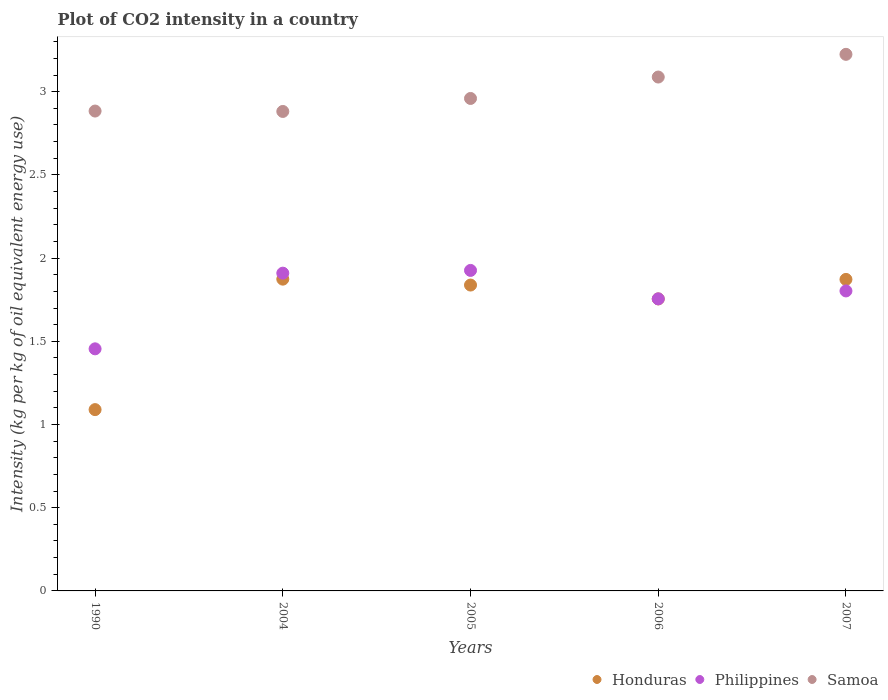Is the number of dotlines equal to the number of legend labels?
Offer a terse response. Yes. What is the CO2 intensity in in Honduras in 2004?
Your response must be concise. 1.87. Across all years, what is the maximum CO2 intensity in in Philippines?
Your response must be concise. 1.93. Across all years, what is the minimum CO2 intensity in in Samoa?
Your answer should be compact. 2.88. In which year was the CO2 intensity in in Philippines maximum?
Your answer should be very brief. 2005. In which year was the CO2 intensity in in Philippines minimum?
Provide a short and direct response. 1990. What is the total CO2 intensity in in Honduras in the graph?
Provide a succinct answer. 8.43. What is the difference between the CO2 intensity in in Philippines in 2004 and that in 2007?
Give a very brief answer. 0.11. What is the difference between the CO2 intensity in in Samoa in 2006 and the CO2 intensity in in Philippines in 2005?
Ensure brevity in your answer.  1.16. What is the average CO2 intensity in in Philippines per year?
Give a very brief answer. 1.77. In the year 2004, what is the difference between the CO2 intensity in in Samoa and CO2 intensity in in Honduras?
Provide a short and direct response. 1.01. What is the ratio of the CO2 intensity in in Honduras in 2006 to that in 2007?
Offer a terse response. 0.94. Is the CO2 intensity in in Samoa in 1990 less than that in 2006?
Keep it short and to the point. Yes. What is the difference between the highest and the second highest CO2 intensity in in Samoa?
Your answer should be very brief. 0.14. What is the difference between the highest and the lowest CO2 intensity in in Philippines?
Keep it short and to the point. 0.47. In how many years, is the CO2 intensity in in Honduras greater than the average CO2 intensity in in Honduras taken over all years?
Make the answer very short. 4. Is it the case that in every year, the sum of the CO2 intensity in in Philippines and CO2 intensity in in Samoa  is greater than the CO2 intensity in in Honduras?
Your response must be concise. Yes. Is the CO2 intensity in in Honduras strictly greater than the CO2 intensity in in Samoa over the years?
Ensure brevity in your answer.  No. What is the difference between two consecutive major ticks on the Y-axis?
Your answer should be very brief. 0.5. Are the values on the major ticks of Y-axis written in scientific E-notation?
Provide a short and direct response. No. Does the graph contain any zero values?
Your answer should be compact. No. Where does the legend appear in the graph?
Offer a very short reply. Bottom right. How many legend labels are there?
Provide a short and direct response. 3. What is the title of the graph?
Make the answer very short. Plot of CO2 intensity in a country. Does "Albania" appear as one of the legend labels in the graph?
Provide a short and direct response. No. What is the label or title of the Y-axis?
Ensure brevity in your answer.  Intensity (kg per kg of oil equivalent energy use). What is the Intensity (kg per kg of oil equivalent energy use) in Honduras in 1990?
Provide a short and direct response. 1.09. What is the Intensity (kg per kg of oil equivalent energy use) in Philippines in 1990?
Your answer should be very brief. 1.45. What is the Intensity (kg per kg of oil equivalent energy use) of Samoa in 1990?
Your answer should be compact. 2.88. What is the Intensity (kg per kg of oil equivalent energy use) of Honduras in 2004?
Keep it short and to the point. 1.87. What is the Intensity (kg per kg of oil equivalent energy use) in Philippines in 2004?
Your answer should be very brief. 1.91. What is the Intensity (kg per kg of oil equivalent energy use) in Samoa in 2004?
Offer a very short reply. 2.88. What is the Intensity (kg per kg of oil equivalent energy use) in Honduras in 2005?
Your response must be concise. 1.84. What is the Intensity (kg per kg of oil equivalent energy use) of Philippines in 2005?
Ensure brevity in your answer.  1.93. What is the Intensity (kg per kg of oil equivalent energy use) of Samoa in 2005?
Give a very brief answer. 2.96. What is the Intensity (kg per kg of oil equivalent energy use) in Honduras in 2006?
Keep it short and to the point. 1.75. What is the Intensity (kg per kg of oil equivalent energy use) of Philippines in 2006?
Offer a terse response. 1.76. What is the Intensity (kg per kg of oil equivalent energy use) of Samoa in 2006?
Provide a short and direct response. 3.09. What is the Intensity (kg per kg of oil equivalent energy use) of Honduras in 2007?
Your answer should be compact. 1.87. What is the Intensity (kg per kg of oil equivalent energy use) in Philippines in 2007?
Give a very brief answer. 1.8. What is the Intensity (kg per kg of oil equivalent energy use) in Samoa in 2007?
Make the answer very short. 3.22. Across all years, what is the maximum Intensity (kg per kg of oil equivalent energy use) of Honduras?
Give a very brief answer. 1.87. Across all years, what is the maximum Intensity (kg per kg of oil equivalent energy use) in Philippines?
Make the answer very short. 1.93. Across all years, what is the maximum Intensity (kg per kg of oil equivalent energy use) of Samoa?
Offer a terse response. 3.22. Across all years, what is the minimum Intensity (kg per kg of oil equivalent energy use) of Honduras?
Make the answer very short. 1.09. Across all years, what is the minimum Intensity (kg per kg of oil equivalent energy use) in Philippines?
Offer a terse response. 1.45. Across all years, what is the minimum Intensity (kg per kg of oil equivalent energy use) in Samoa?
Ensure brevity in your answer.  2.88. What is the total Intensity (kg per kg of oil equivalent energy use) of Honduras in the graph?
Provide a succinct answer. 8.43. What is the total Intensity (kg per kg of oil equivalent energy use) in Philippines in the graph?
Your response must be concise. 8.85. What is the total Intensity (kg per kg of oil equivalent energy use) in Samoa in the graph?
Your answer should be compact. 15.04. What is the difference between the Intensity (kg per kg of oil equivalent energy use) in Honduras in 1990 and that in 2004?
Your response must be concise. -0.78. What is the difference between the Intensity (kg per kg of oil equivalent energy use) in Philippines in 1990 and that in 2004?
Make the answer very short. -0.45. What is the difference between the Intensity (kg per kg of oil equivalent energy use) of Samoa in 1990 and that in 2004?
Make the answer very short. 0. What is the difference between the Intensity (kg per kg of oil equivalent energy use) of Honduras in 1990 and that in 2005?
Make the answer very short. -0.75. What is the difference between the Intensity (kg per kg of oil equivalent energy use) of Philippines in 1990 and that in 2005?
Give a very brief answer. -0.47. What is the difference between the Intensity (kg per kg of oil equivalent energy use) in Samoa in 1990 and that in 2005?
Provide a succinct answer. -0.08. What is the difference between the Intensity (kg per kg of oil equivalent energy use) in Honduras in 1990 and that in 2006?
Provide a short and direct response. -0.67. What is the difference between the Intensity (kg per kg of oil equivalent energy use) of Philippines in 1990 and that in 2006?
Make the answer very short. -0.3. What is the difference between the Intensity (kg per kg of oil equivalent energy use) of Samoa in 1990 and that in 2006?
Your response must be concise. -0.2. What is the difference between the Intensity (kg per kg of oil equivalent energy use) of Honduras in 1990 and that in 2007?
Offer a terse response. -0.78. What is the difference between the Intensity (kg per kg of oil equivalent energy use) of Philippines in 1990 and that in 2007?
Provide a short and direct response. -0.35. What is the difference between the Intensity (kg per kg of oil equivalent energy use) in Samoa in 1990 and that in 2007?
Your response must be concise. -0.34. What is the difference between the Intensity (kg per kg of oil equivalent energy use) in Honduras in 2004 and that in 2005?
Provide a succinct answer. 0.04. What is the difference between the Intensity (kg per kg of oil equivalent energy use) of Philippines in 2004 and that in 2005?
Make the answer very short. -0.02. What is the difference between the Intensity (kg per kg of oil equivalent energy use) of Samoa in 2004 and that in 2005?
Give a very brief answer. -0.08. What is the difference between the Intensity (kg per kg of oil equivalent energy use) of Honduras in 2004 and that in 2006?
Offer a terse response. 0.12. What is the difference between the Intensity (kg per kg of oil equivalent energy use) of Philippines in 2004 and that in 2006?
Keep it short and to the point. 0.15. What is the difference between the Intensity (kg per kg of oil equivalent energy use) of Samoa in 2004 and that in 2006?
Your answer should be compact. -0.21. What is the difference between the Intensity (kg per kg of oil equivalent energy use) in Honduras in 2004 and that in 2007?
Keep it short and to the point. 0. What is the difference between the Intensity (kg per kg of oil equivalent energy use) of Philippines in 2004 and that in 2007?
Give a very brief answer. 0.11. What is the difference between the Intensity (kg per kg of oil equivalent energy use) of Samoa in 2004 and that in 2007?
Offer a very short reply. -0.34. What is the difference between the Intensity (kg per kg of oil equivalent energy use) in Honduras in 2005 and that in 2006?
Your response must be concise. 0.08. What is the difference between the Intensity (kg per kg of oil equivalent energy use) of Philippines in 2005 and that in 2006?
Offer a very short reply. 0.17. What is the difference between the Intensity (kg per kg of oil equivalent energy use) of Samoa in 2005 and that in 2006?
Your answer should be compact. -0.13. What is the difference between the Intensity (kg per kg of oil equivalent energy use) in Honduras in 2005 and that in 2007?
Provide a succinct answer. -0.03. What is the difference between the Intensity (kg per kg of oil equivalent energy use) in Philippines in 2005 and that in 2007?
Provide a short and direct response. 0.12. What is the difference between the Intensity (kg per kg of oil equivalent energy use) of Samoa in 2005 and that in 2007?
Provide a succinct answer. -0.27. What is the difference between the Intensity (kg per kg of oil equivalent energy use) in Honduras in 2006 and that in 2007?
Your response must be concise. -0.12. What is the difference between the Intensity (kg per kg of oil equivalent energy use) of Philippines in 2006 and that in 2007?
Provide a short and direct response. -0.05. What is the difference between the Intensity (kg per kg of oil equivalent energy use) in Samoa in 2006 and that in 2007?
Offer a very short reply. -0.14. What is the difference between the Intensity (kg per kg of oil equivalent energy use) in Honduras in 1990 and the Intensity (kg per kg of oil equivalent energy use) in Philippines in 2004?
Give a very brief answer. -0.82. What is the difference between the Intensity (kg per kg of oil equivalent energy use) of Honduras in 1990 and the Intensity (kg per kg of oil equivalent energy use) of Samoa in 2004?
Provide a short and direct response. -1.79. What is the difference between the Intensity (kg per kg of oil equivalent energy use) of Philippines in 1990 and the Intensity (kg per kg of oil equivalent energy use) of Samoa in 2004?
Make the answer very short. -1.43. What is the difference between the Intensity (kg per kg of oil equivalent energy use) in Honduras in 1990 and the Intensity (kg per kg of oil equivalent energy use) in Philippines in 2005?
Your answer should be compact. -0.84. What is the difference between the Intensity (kg per kg of oil equivalent energy use) in Honduras in 1990 and the Intensity (kg per kg of oil equivalent energy use) in Samoa in 2005?
Your response must be concise. -1.87. What is the difference between the Intensity (kg per kg of oil equivalent energy use) of Philippines in 1990 and the Intensity (kg per kg of oil equivalent energy use) of Samoa in 2005?
Your answer should be very brief. -1.5. What is the difference between the Intensity (kg per kg of oil equivalent energy use) in Honduras in 1990 and the Intensity (kg per kg of oil equivalent energy use) in Philippines in 2006?
Your answer should be very brief. -0.67. What is the difference between the Intensity (kg per kg of oil equivalent energy use) of Honduras in 1990 and the Intensity (kg per kg of oil equivalent energy use) of Samoa in 2006?
Provide a succinct answer. -2. What is the difference between the Intensity (kg per kg of oil equivalent energy use) of Philippines in 1990 and the Intensity (kg per kg of oil equivalent energy use) of Samoa in 2006?
Your answer should be very brief. -1.63. What is the difference between the Intensity (kg per kg of oil equivalent energy use) of Honduras in 1990 and the Intensity (kg per kg of oil equivalent energy use) of Philippines in 2007?
Your answer should be compact. -0.71. What is the difference between the Intensity (kg per kg of oil equivalent energy use) of Honduras in 1990 and the Intensity (kg per kg of oil equivalent energy use) of Samoa in 2007?
Your answer should be very brief. -2.13. What is the difference between the Intensity (kg per kg of oil equivalent energy use) of Philippines in 1990 and the Intensity (kg per kg of oil equivalent energy use) of Samoa in 2007?
Offer a terse response. -1.77. What is the difference between the Intensity (kg per kg of oil equivalent energy use) in Honduras in 2004 and the Intensity (kg per kg of oil equivalent energy use) in Philippines in 2005?
Ensure brevity in your answer.  -0.05. What is the difference between the Intensity (kg per kg of oil equivalent energy use) of Honduras in 2004 and the Intensity (kg per kg of oil equivalent energy use) of Samoa in 2005?
Your answer should be very brief. -1.09. What is the difference between the Intensity (kg per kg of oil equivalent energy use) of Philippines in 2004 and the Intensity (kg per kg of oil equivalent energy use) of Samoa in 2005?
Make the answer very short. -1.05. What is the difference between the Intensity (kg per kg of oil equivalent energy use) of Honduras in 2004 and the Intensity (kg per kg of oil equivalent energy use) of Philippines in 2006?
Your answer should be compact. 0.12. What is the difference between the Intensity (kg per kg of oil equivalent energy use) in Honduras in 2004 and the Intensity (kg per kg of oil equivalent energy use) in Samoa in 2006?
Make the answer very short. -1.21. What is the difference between the Intensity (kg per kg of oil equivalent energy use) of Philippines in 2004 and the Intensity (kg per kg of oil equivalent energy use) of Samoa in 2006?
Offer a very short reply. -1.18. What is the difference between the Intensity (kg per kg of oil equivalent energy use) in Honduras in 2004 and the Intensity (kg per kg of oil equivalent energy use) in Philippines in 2007?
Keep it short and to the point. 0.07. What is the difference between the Intensity (kg per kg of oil equivalent energy use) of Honduras in 2004 and the Intensity (kg per kg of oil equivalent energy use) of Samoa in 2007?
Give a very brief answer. -1.35. What is the difference between the Intensity (kg per kg of oil equivalent energy use) of Philippines in 2004 and the Intensity (kg per kg of oil equivalent energy use) of Samoa in 2007?
Make the answer very short. -1.31. What is the difference between the Intensity (kg per kg of oil equivalent energy use) in Honduras in 2005 and the Intensity (kg per kg of oil equivalent energy use) in Philippines in 2006?
Make the answer very short. 0.08. What is the difference between the Intensity (kg per kg of oil equivalent energy use) of Honduras in 2005 and the Intensity (kg per kg of oil equivalent energy use) of Samoa in 2006?
Make the answer very short. -1.25. What is the difference between the Intensity (kg per kg of oil equivalent energy use) of Philippines in 2005 and the Intensity (kg per kg of oil equivalent energy use) of Samoa in 2006?
Your answer should be very brief. -1.16. What is the difference between the Intensity (kg per kg of oil equivalent energy use) in Honduras in 2005 and the Intensity (kg per kg of oil equivalent energy use) in Philippines in 2007?
Provide a short and direct response. 0.04. What is the difference between the Intensity (kg per kg of oil equivalent energy use) of Honduras in 2005 and the Intensity (kg per kg of oil equivalent energy use) of Samoa in 2007?
Make the answer very short. -1.39. What is the difference between the Intensity (kg per kg of oil equivalent energy use) in Philippines in 2005 and the Intensity (kg per kg of oil equivalent energy use) in Samoa in 2007?
Provide a short and direct response. -1.3. What is the difference between the Intensity (kg per kg of oil equivalent energy use) in Honduras in 2006 and the Intensity (kg per kg of oil equivalent energy use) in Philippines in 2007?
Provide a succinct answer. -0.05. What is the difference between the Intensity (kg per kg of oil equivalent energy use) of Honduras in 2006 and the Intensity (kg per kg of oil equivalent energy use) of Samoa in 2007?
Keep it short and to the point. -1.47. What is the difference between the Intensity (kg per kg of oil equivalent energy use) of Philippines in 2006 and the Intensity (kg per kg of oil equivalent energy use) of Samoa in 2007?
Keep it short and to the point. -1.47. What is the average Intensity (kg per kg of oil equivalent energy use) in Honduras per year?
Your response must be concise. 1.69. What is the average Intensity (kg per kg of oil equivalent energy use) in Philippines per year?
Your answer should be very brief. 1.77. What is the average Intensity (kg per kg of oil equivalent energy use) of Samoa per year?
Provide a short and direct response. 3.01. In the year 1990, what is the difference between the Intensity (kg per kg of oil equivalent energy use) of Honduras and Intensity (kg per kg of oil equivalent energy use) of Philippines?
Offer a very short reply. -0.37. In the year 1990, what is the difference between the Intensity (kg per kg of oil equivalent energy use) of Honduras and Intensity (kg per kg of oil equivalent energy use) of Samoa?
Ensure brevity in your answer.  -1.79. In the year 1990, what is the difference between the Intensity (kg per kg of oil equivalent energy use) in Philippines and Intensity (kg per kg of oil equivalent energy use) in Samoa?
Make the answer very short. -1.43. In the year 2004, what is the difference between the Intensity (kg per kg of oil equivalent energy use) in Honduras and Intensity (kg per kg of oil equivalent energy use) in Philippines?
Make the answer very short. -0.04. In the year 2004, what is the difference between the Intensity (kg per kg of oil equivalent energy use) of Honduras and Intensity (kg per kg of oil equivalent energy use) of Samoa?
Keep it short and to the point. -1.01. In the year 2004, what is the difference between the Intensity (kg per kg of oil equivalent energy use) of Philippines and Intensity (kg per kg of oil equivalent energy use) of Samoa?
Provide a short and direct response. -0.97. In the year 2005, what is the difference between the Intensity (kg per kg of oil equivalent energy use) of Honduras and Intensity (kg per kg of oil equivalent energy use) of Philippines?
Give a very brief answer. -0.09. In the year 2005, what is the difference between the Intensity (kg per kg of oil equivalent energy use) of Honduras and Intensity (kg per kg of oil equivalent energy use) of Samoa?
Your answer should be very brief. -1.12. In the year 2005, what is the difference between the Intensity (kg per kg of oil equivalent energy use) in Philippines and Intensity (kg per kg of oil equivalent energy use) in Samoa?
Make the answer very short. -1.03. In the year 2006, what is the difference between the Intensity (kg per kg of oil equivalent energy use) of Honduras and Intensity (kg per kg of oil equivalent energy use) of Philippines?
Provide a succinct answer. -0. In the year 2006, what is the difference between the Intensity (kg per kg of oil equivalent energy use) in Honduras and Intensity (kg per kg of oil equivalent energy use) in Samoa?
Provide a short and direct response. -1.33. In the year 2006, what is the difference between the Intensity (kg per kg of oil equivalent energy use) in Philippines and Intensity (kg per kg of oil equivalent energy use) in Samoa?
Offer a terse response. -1.33. In the year 2007, what is the difference between the Intensity (kg per kg of oil equivalent energy use) of Honduras and Intensity (kg per kg of oil equivalent energy use) of Philippines?
Your response must be concise. 0.07. In the year 2007, what is the difference between the Intensity (kg per kg of oil equivalent energy use) in Honduras and Intensity (kg per kg of oil equivalent energy use) in Samoa?
Make the answer very short. -1.35. In the year 2007, what is the difference between the Intensity (kg per kg of oil equivalent energy use) of Philippines and Intensity (kg per kg of oil equivalent energy use) of Samoa?
Ensure brevity in your answer.  -1.42. What is the ratio of the Intensity (kg per kg of oil equivalent energy use) of Honduras in 1990 to that in 2004?
Give a very brief answer. 0.58. What is the ratio of the Intensity (kg per kg of oil equivalent energy use) in Philippines in 1990 to that in 2004?
Your answer should be compact. 0.76. What is the ratio of the Intensity (kg per kg of oil equivalent energy use) of Samoa in 1990 to that in 2004?
Give a very brief answer. 1. What is the ratio of the Intensity (kg per kg of oil equivalent energy use) of Honduras in 1990 to that in 2005?
Give a very brief answer. 0.59. What is the ratio of the Intensity (kg per kg of oil equivalent energy use) of Philippines in 1990 to that in 2005?
Offer a very short reply. 0.76. What is the ratio of the Intensity (kg per kg of oil equivalent energy use) in Samoa in 1990 to that in 2005?
Keep it short and to the point. 0.97. What is the ratio of the Intensity (kg per kg of oil equivalent energy use) in Honduras in 1990 to that in 2006?
Your response must be concise. 0.62. What is the ratio of the Intensity (kg per kg of oil equivalent energy use) of Philippines in 1990 to that in 2006?
Provide a succinct answer. 0.83. What is the ratio of the Intensity (kg per kg of oil equivalent energy use) in Samoa in 1990 to that in 2006?
Your answer should be compact. 0.93. What is the ratio of the Intensity (kg per kg of oil equivalent energy use) in Honduras in 1990 to that in 2007?
Your answer should be compact. 0.58. What is the ratio of the Intensity (kg per kg of oil equivalent energy use) of Philippines in 1990 to that in 2007?
Your answer should be compact. 0.81. What is the ratio of the Intensity (kg per kg of oil equivalent energy use) in Samoa in 1990 to that in 2007?
Your response must be concise. 0.89. What is the ratio of the Intensity (kg per kg of oil equivalent energy use) of Honduras in 2004 to that in 2005?
Provide a short and direct response. 1.02. What is the ratio of the Intensity (kg per kg of oil equivalent energy use) in Philippines in 2004 to that in 2005?
Ensure brevity in your answer.  0.99. What is the ratio of the Intensity (kg per kg of oil equivalent energy use) in Samoa in 2004 to that in 2005?
Your answer should be compact. 0.97. What is the ratio of the Intensity (kg per kg of oil equivalent energy use) of Honduras in 2004 to that in 2006?
Offer a terse response. 1.07. What is the ratio of the Intensity (kg per kg of oil equivalent energy use) in Philippines in 2004 to that in 2006?
Offer a terse response. 1.09. What is the ratio of the Intensity (kg per kg of oil equivalent energy use) in Samoa in 2004 to that in 2006?
Provide a succinct answer. 0.93. What is the ratio of the Intensity (kg per kg of oil equivalent energy use) of Honduras in 2004 to that in 2007?
Ensure brevity in your answer.  1. What is the ratio of the Intensity (kg per kg of oil equivalent energy use) in Philippines in 2004 to that in 2007?
Keep it short and to the point. 1.06. What is the ratio of the Intensity (kg per kg of oil equivalent energy use) in Samoa in 2004 to that in 2007?
Give a very brief answer. 0.89. What is the ratio of the Intensity (kg per kg of oil equivalent energy use) of Honduras in 2005 to that in 2006?
Offer a terse response. 1.05. What is the ratio of the Intensity (kg per kg of oil equivalent energy use) in Philippines in 2005 to that in 2006?
Provide a succinct answer. 1.1. What is the ratio of the Intensity (kg per kg of oil equivalent energy use) in Honduras in 2005 to that in 2007?
Offer a terse response. 0.98. What is the ratio of the Intensity (kg per kg of oil equivalent energy use) of Philippines in 2005 to that in 2007?
Provide a short and direct response. 1.07. What is the ratio of the Intensity (kg per kg of oil equivalent energy use) in Samoa in 2005 to that in 2007?
Provide a succinct answer. 0.92. What is the ratio of the Intensity (kg per kg of oil equivalent energy use) of Honduras in 2006 to that in 2007?
Provide a succinct answer. 0.94. What is the ratio of the Intensity (kg per kg of oil equivalent energy use) in Philippines in 2006 to that in 2007?
Your response must be concise. 0.97. What is the ratio of the Intensity (kg per kg of oil equivalent energy use) in Samoa in 2006 to that in 2007?
Make the answer very short. 0.96. What is the difference between the highest and the second highest Intensity (kg per kg of oil equivalent energy use) of Honduras?
Your answer should be very brief. 0. What is the difference between the highest and the second highest Intensity (kg per kg of oil equivalent energy use) in Philippines?
Offer a very short reply. 0.02. What is the difference between the highest and the second highest Intensity (kg per kg of oil equivalent energy use) in Samoa?
Make the answer very short. 0.14. What is the difference between the highest and the lowest Intensity (kg per kg of oil equivalent energy use) of Honduras?
Keep it short and to the point. 0.78. What is the difference between the highest and the lowest Intensity (kg per kg of oil equivalent energy use) of Philippines?
Offer a very short reply. 0.47. What is the difference between the highest and the lowest Intensity (kg per kg of oil equivalent energy use) of Samoa?
Keep it short and to the point. 0.34. 